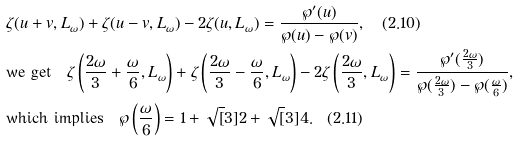Convert formula to latex. <formula><loc_0><loc_0><loc_500><loc_500>& \zeta ( u + v , L _ { \omega } ) + \zeta ( u - v , L _ { \omega } ) - 2 \zeta ( u , L _ { \omega } ) = \frac { \wp ^ { \prime } ( u ) } { \wp ( u ) - \wp ( v ) } , \quad ( 2 . 1 0 ) \\ & \text {we get} \quad \zeta \left ( \frac { 2 \omega } { 3 } + \frac { \omega } { 6 } , L _ { \omega } \right ) + \zeta \left ( \frac { 2 \omega } { 3 } - \frac { \omega } { 6 } , L _ { \omega } \right ) - 2 \zeta \left ( \frac { 2 \omega } { 3 } , L _ { \omega } \right ) = \frac { \wp ^ { \prime } ( \frac { 2 \omega } { 3 } ) } { \wp ( \frac { 2 \omega } { 3 } ) - \wp ( \frac { \omega } { 6 } ) } , \\ & \text {which implies} \quad \wp \left ( \frac { \omega } { 6 } \right ) = 1 + \sqrt { [ } 3 ] { 2 } + \sqrt { [ } 3 ] { 4 } . \quad ( 2 . 1 1 )</formula> 